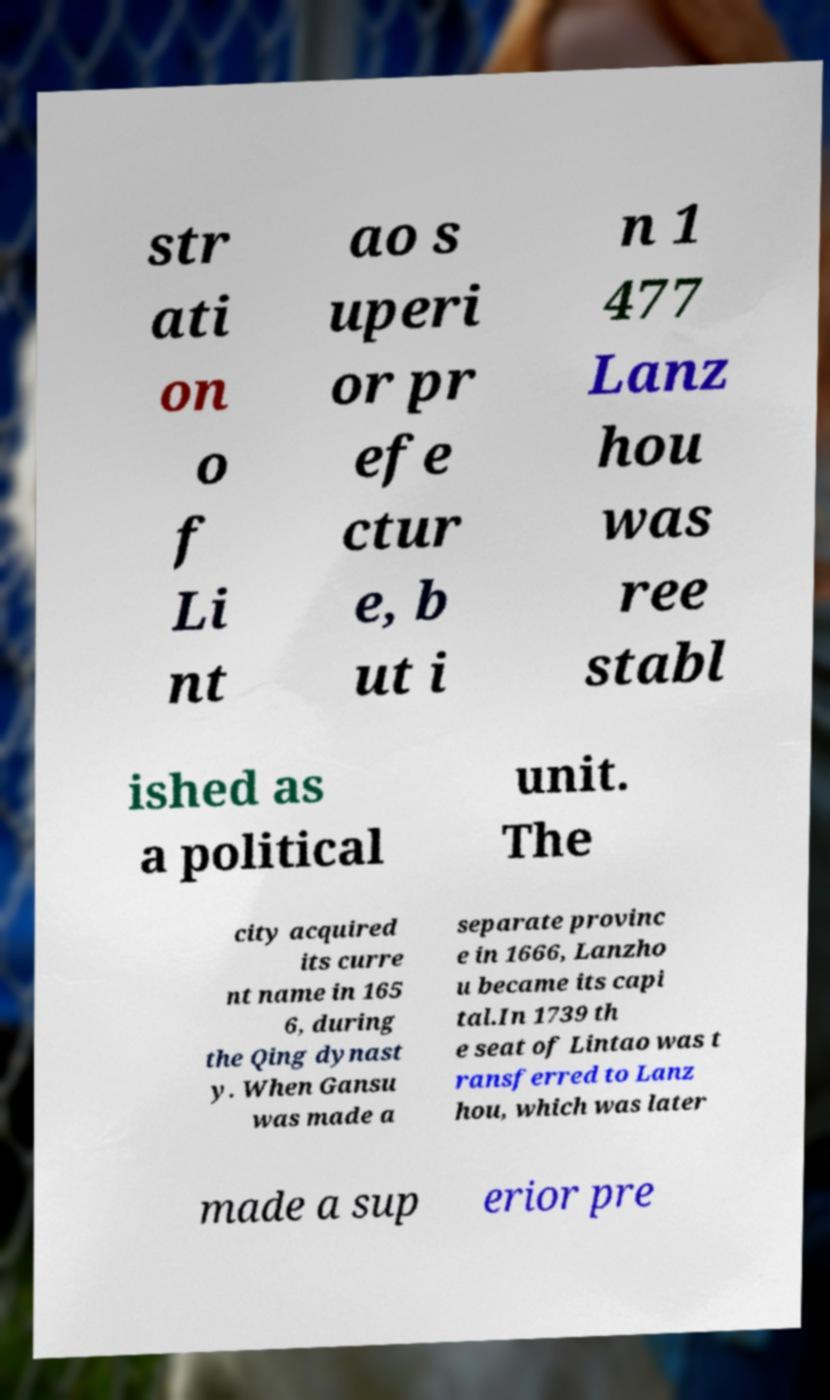What messages or text are displayed in this image? I need them in a readable, typed format. str ati on o f Li nt ao s uperi or pr efe ctur e, b ut i n 1 477 Lanz hou was ree stabl ished as a political unit. The city acquired its curre nt name in 165 6, during the Qing dynast y. When Gansu was made a separate provinc e in 1666, Lanzho u became its capi tal.In 1739 th e seat of Lintao was t ransferred to Lanz hou, which was later made a sup erior pre 